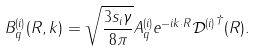<formula> <loc_0><loc_0><loc_500><loc_500>B _ { q } ^ { ( i ) } ( R , k ) = \sqrt { \frac { 3 s _ { i } \gamma } { 8 \pi } } A _ { q } ^ { ( i ) } e ^ { - i k \cdot R } { \mathcal { D } ^ { ( i ) } } ^ { \dagger } ( R ) .</formula> 